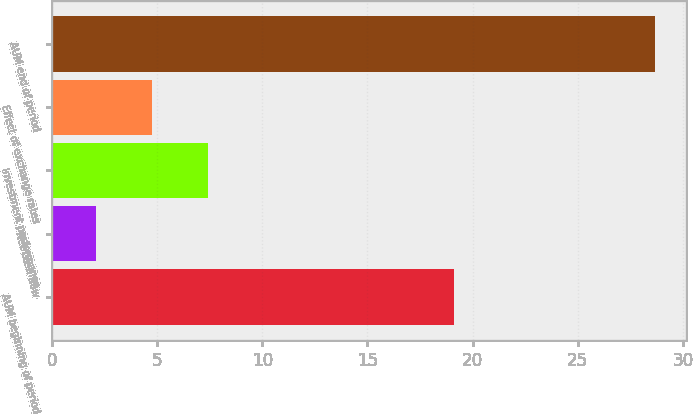<chart> <loc_0><loc_0><loc_500><loc_500><bar_chart><fcel>AUM beginning of period<fcel>Net cash flow<fcel>Investment performance<fcel>Effect of exchange rates<fcel>AUM end of period<nl><fcel>19.1<fcel>2.1<fcel>7.42<fcel>4.76<fcel>28.7<nl></chart> 